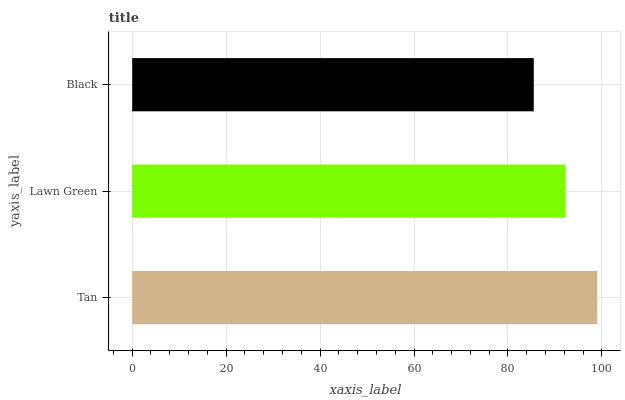Is Black the minimum?
Answer yes or no. Yes. Is Tan the maximum?
Answer yes or no. Yes. Is Lawn Green the minimum?
Answer yes or no. No. Is Lawn Green the maximum?
Answer yes or no. No. Is Tan greater than Lawn Green?
Answer yes or no. Yes. Is Lawn Green less than Tan?
Answer yes or no. Yes. Is Lawn Green greater than Tan?
Answer yes or no. No. Is Tan less than Lawn Green?
Answer yes or no. No. Is Lawn Green the high median?
Answer yes or no. Yes. Is Lawn Green the low median?
Answer yes or no. Yes. Is Black the high median?
Answer yes or no. No. Is Tan the low median?
Answer yes or no. No. 